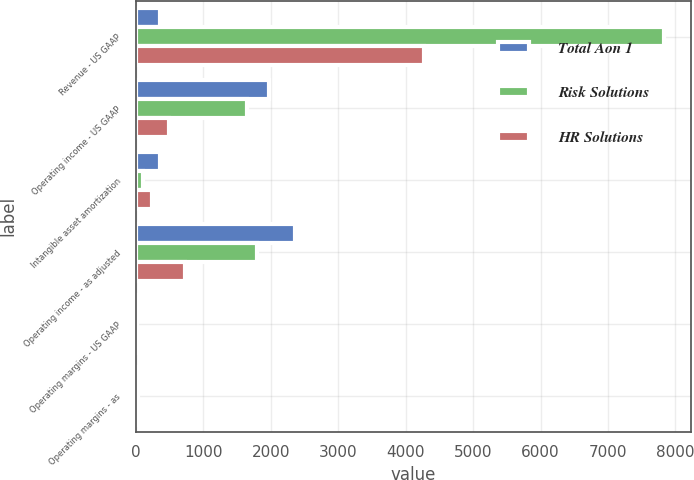Convert chart to OTSL. <chart><loc_0><loc_0><loc_500><loc_500><stacked_bar_chart><ecel><fcel>Revenue - US GAAP<fcel>Operating income - US GAAP<fcel>Intangible asset amortization<fcel>Operating income - as adjusted<fcel>Operating margins - US GAAP<fcel>Operating margins - as<nl><fcel>Total Aon 1<fcel>352<fcel>1966<fcel>352<fcel>2353<fcel>16.3<fcel>19.5<nl><fcel>Risk Solutions<fcel>7834<fcel>1648<fcel>109<fcel>1792<fcel>21<fcel>22.9<nl><fcel>HR Solutions<fcel>4264<fcel>485<fcel>243<fcel>728<fcel>11.4<fcel>17.1<nl></chart> 